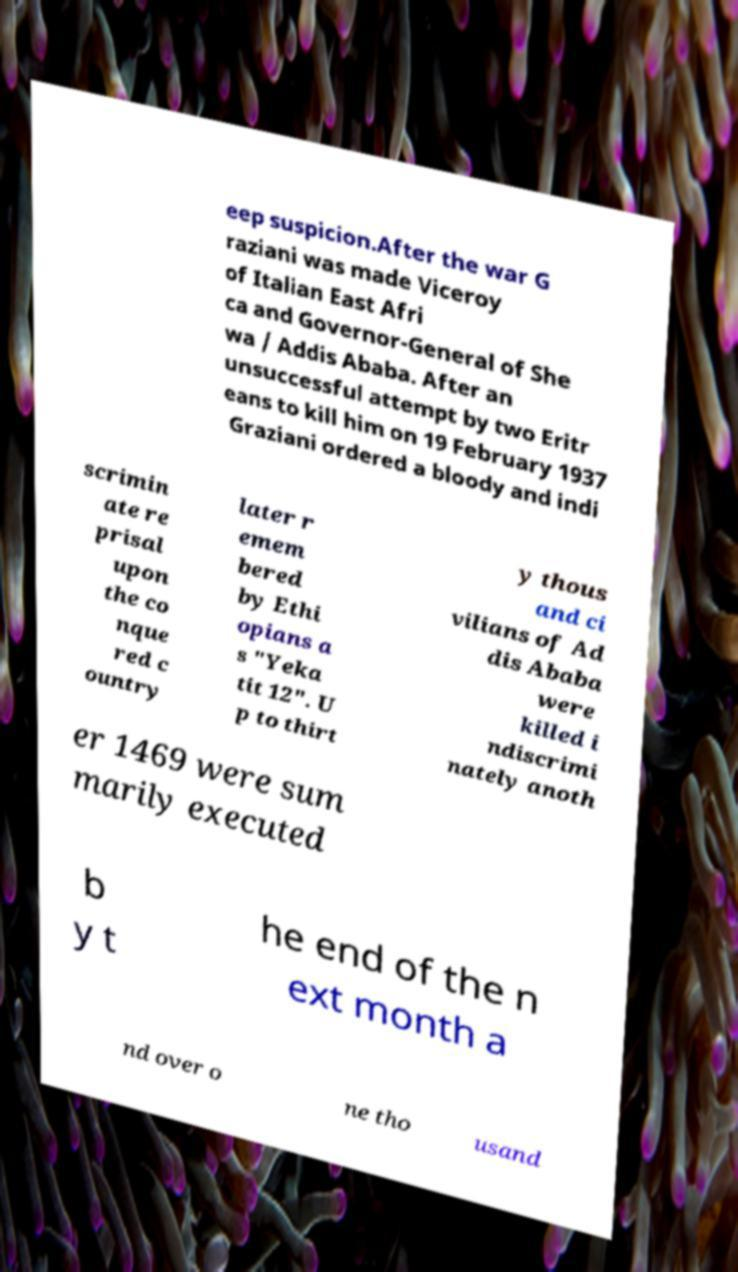Can you read and provide the text displayed in the image?This photo seems to have some interesting text. Can you extract and type it out for me? eep suspicion.After the war G raziani was made Viceroy of Italian East Afri ca and Governor-General of She wa / Addis Ababa. After an unsuccessful attempt by two Eritr eans to kill him on 19 February 1937 Graziani ordered a bloody and indi scrimin ate re prisal upon the co nque red c ountry later r emem bered by Ethi opians a s "Yeka tit 12". U p to thirt y thous and ci vilians of Ad dis Ababa were killed i ndiscrimi nately anoth er 1469 were sum marily executed b y t he end of the n ext month a nd over o ne tho usand 